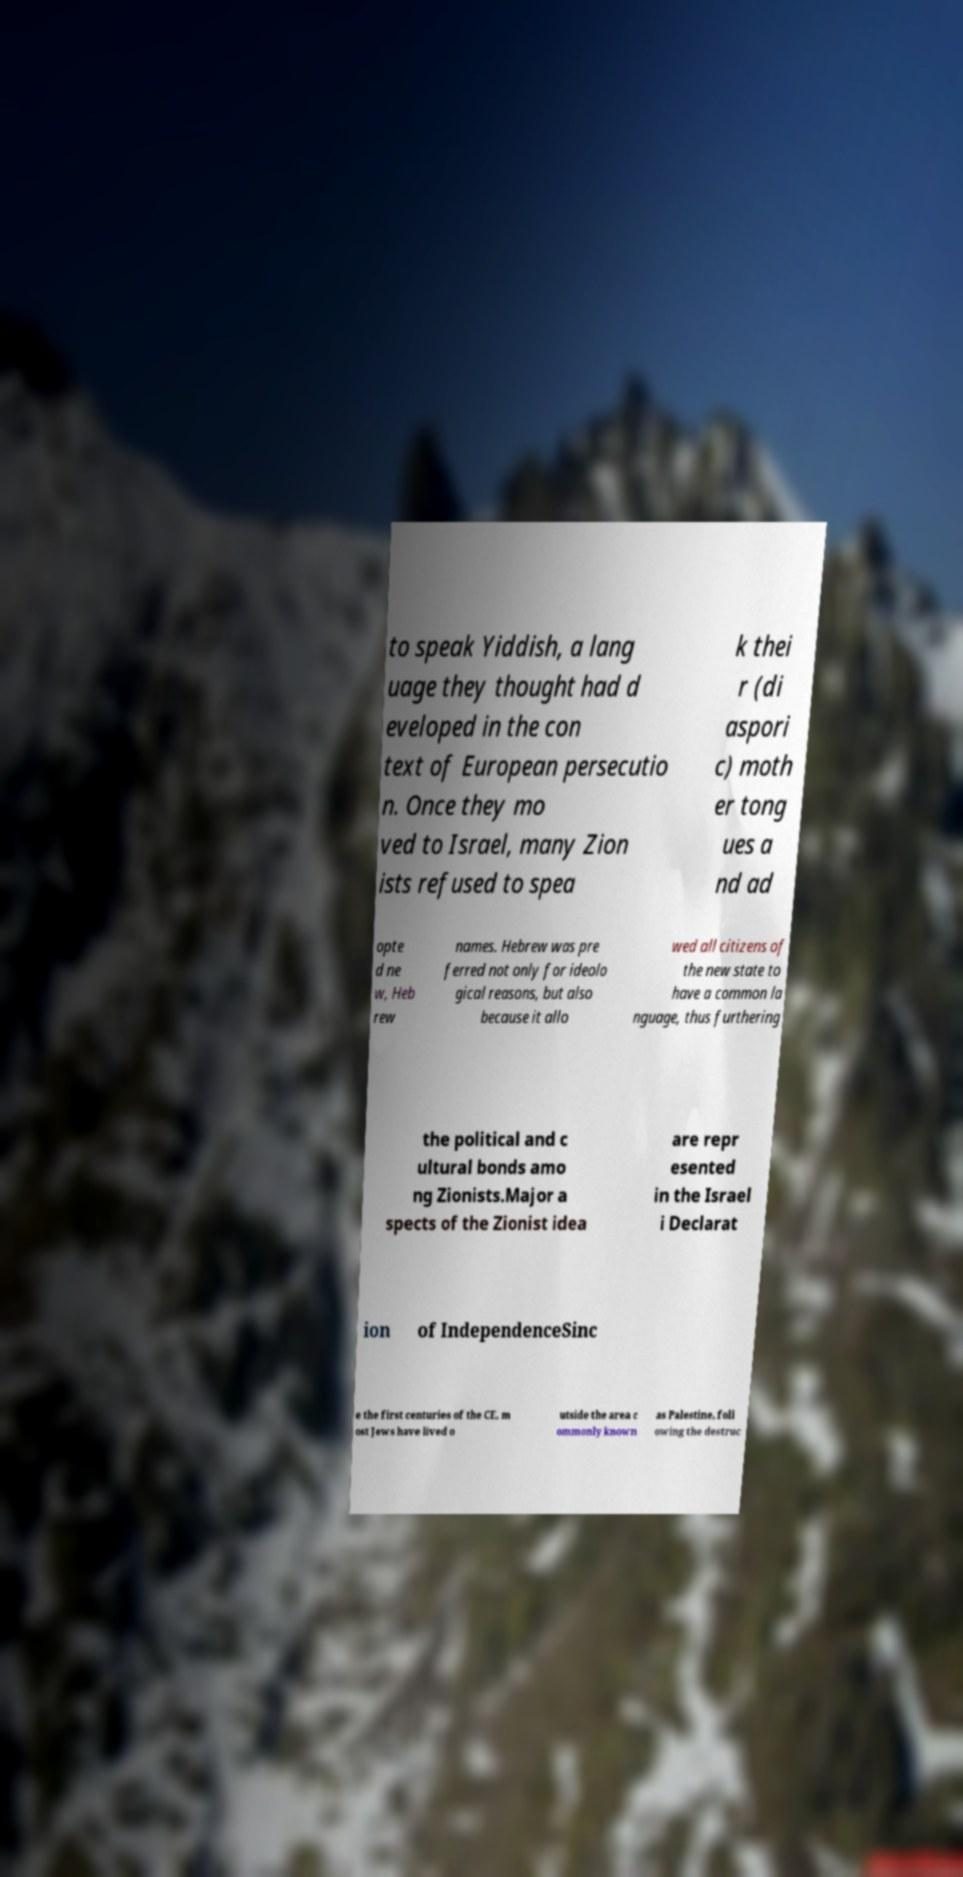Can you accurately transcribe the text from the provided image for me? to speak Yiddish, a lang uage they thought had d eveloped in the con text of European persecutio n. Once they mo ved to Israel, many Zion ists refused to spea k thei r (di aspori c) moth er tong ues a nd ad opte d ne w, Heb rew names. Hebrew was pre ferred not only for ideolo gical reasons, but also because it allo wed all citizens of the new state to have a common la nguage, thus furthering the political and c ultural bonds amo ng Zionists.Major a spects of the Zionist idea are repr esented in the Israel i Declarat ion of IndependenceSinc e the first centuries of the CE, m ost Jews have lived o utside the area c ommonly known as Palestine, foll owing the destruc 